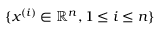Convert formula to latex. <formula><loc_0><loc_0><loc_500><loc_500>\{ x ^ { ( i ) } \in \mathbb { R } ^ { n } , 1 \leq i \leq n \}</formula> 